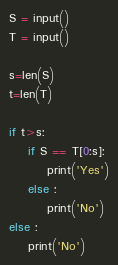Convert code to text. <code><loc_0><loc_0><loc_500><loc_500><_Python_>S = input()
T = input()

s=len(S)
t=len(T)

if t>s:
    if S == T[0:s]:
        print('Yes')
    else :
        print('No')
else :
    print('No')</code> 